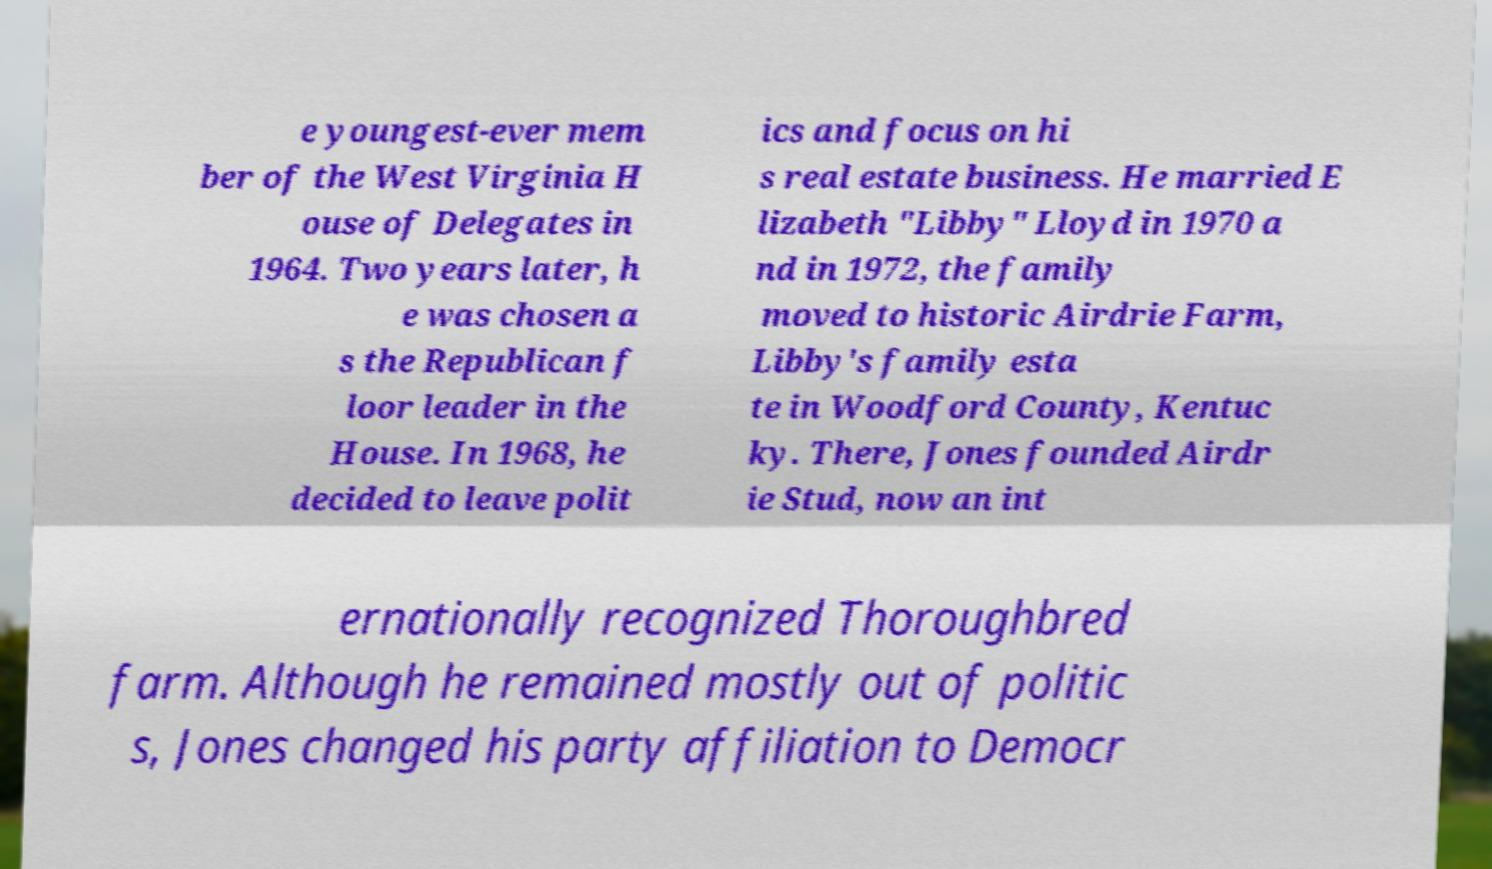Please identify and transcribe the text found in this image. e youngest-ever mem ber of the West Virginia H ouse of Delegates in 1964. Two years later, h e was chosen a s the Republican f loor leader in the House. In 1968, he decided to leave polit ics and focus on hi s real estate business. He married E lizabeth "Libby" Lloyd in 1970 a nd in 1972, the family moved to historic Airdrie Farm, Libby's family esta te in Woodford County, Kentuc ky. There, Jones founded Airdr ie Stud, now an int ernationally recognized Thoroughbred farm. Although he remained mostly out of politic s, Jones changed his party affiliation to Democr 